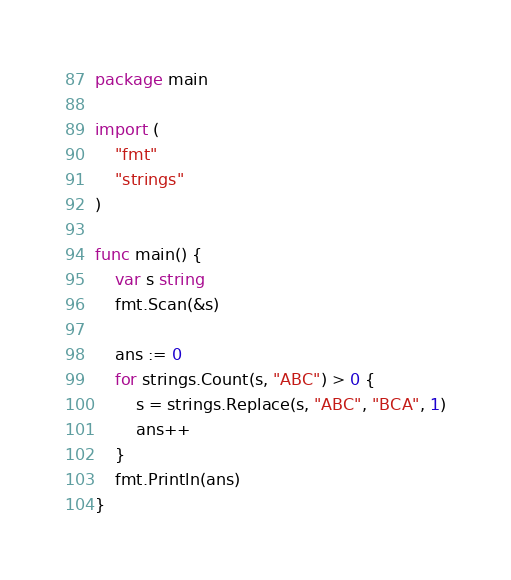Convert code to text. <code><loc_0><loc_0><loc_500><loc_500><_Go_>package main

import (
	"fmt"
	"strings"
)

func main() {
	var s string
	fmt.Scan(&s)

	ans := 0
	for strings.Count(s, "ABC") > 0 {
		s = strings.Replace(s, "ABC", "BCA", 1)
		ans++
	}
	fmt.Println(ans)
}
</code> 